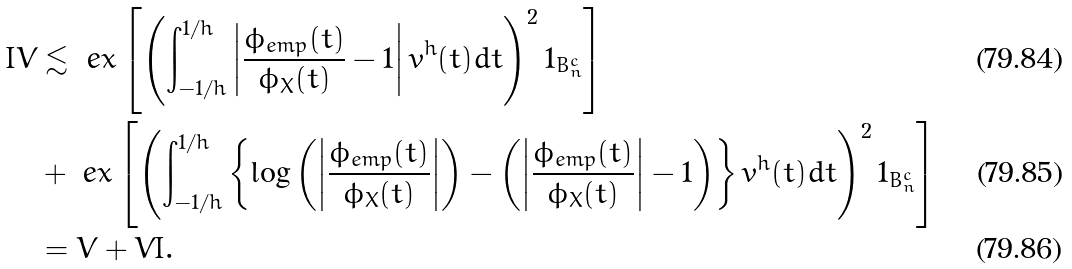Convert formula to latex. <formula><loc_0><loc_0><loc_500><loc_500>I V & \lesssim \ e x \left [ \left ( \int _ { - 1 / h } ^ { 1 / h } \left | \frac { \phi _ { e m p } ( t ) } { \phi _ { X } ( t ) } - 1 \right | v ^ { h } ( t ) d t \right ) ^ { 2 } 1 _ { B _ { n } ^ { c } } \right ] \\ & + \ e x \left [ \left ( \int _ { - 1 / h } ^ { 1 / h } \left \{ \log \left ( \left | \frac { \phi _ { e m p } ( t ) } { \phi _ { X } ( t ) } \right | \right ) - \left ( \left | \frac { \phi _ { e m p } ( t ) } { \phi _ { X } ( t ) } \right | - 1 \right ) \right \} v ^ { h } ( t ) d t \right ) ^ { 2 } 1 _ { B _ { n } ^ { c } } \right ] \\ & = V + V I .</formula> 